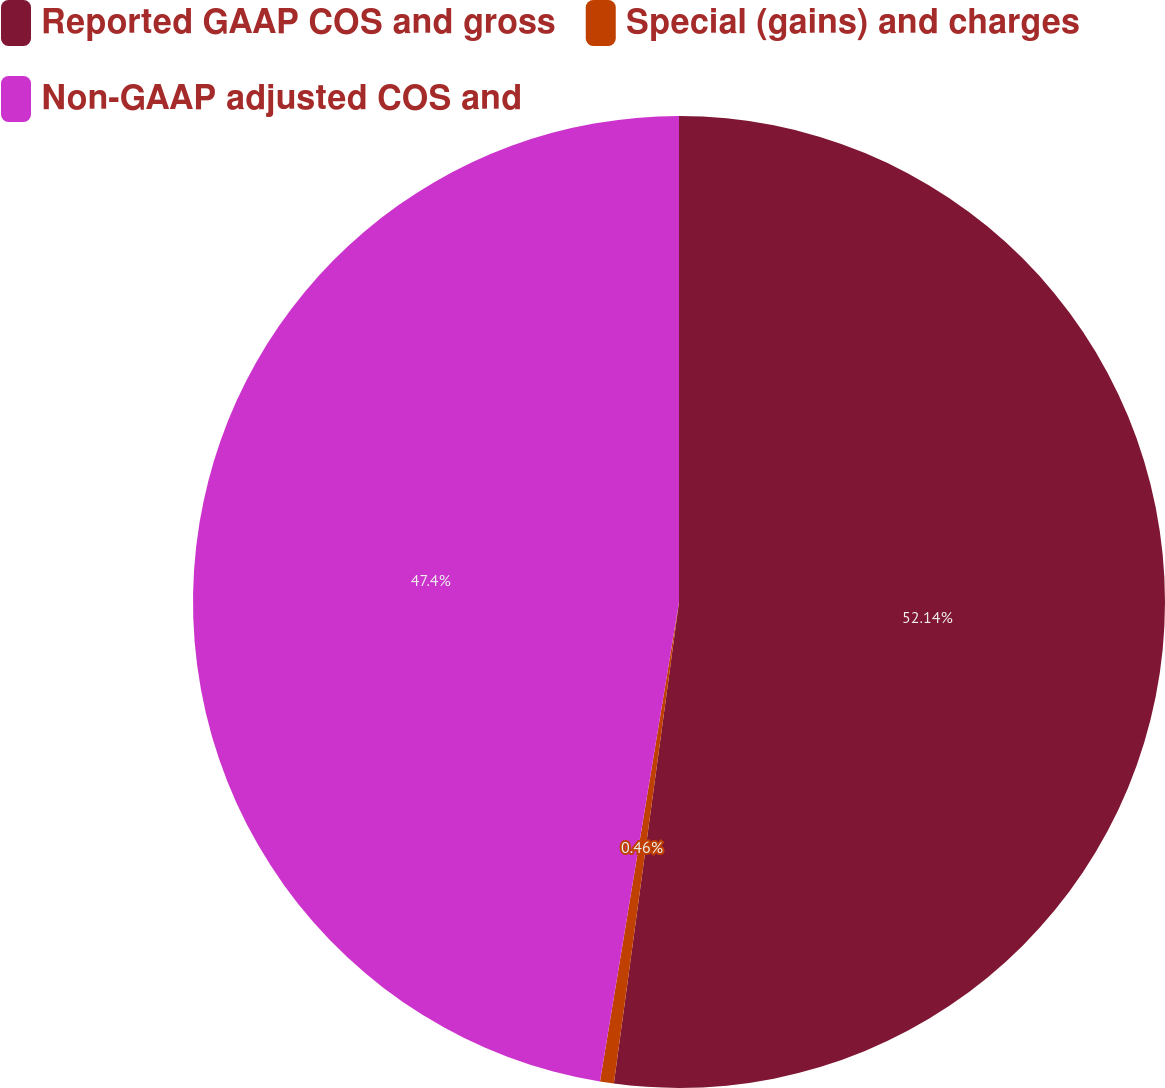Convert chart. <chart><loc_0><loc_0><loc_500><loc_500><pie_chart><fcel>Reported GAAP COS and gross<fcel>Special (gains) and charges<fcel>Non-GAAP adjusted COS and<nl><fcel>52.14%<fcel>0.46%<fcel>47.4%<nl></chart> 